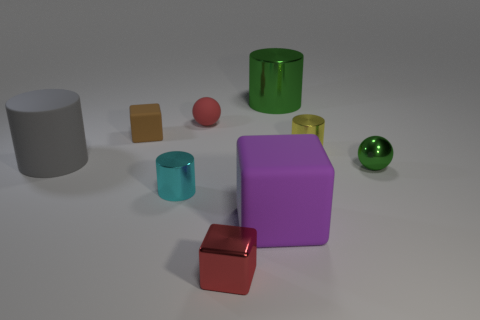Subtract all cylinders. How many objects are left? 5 Add 1 large things. How many large things are left? 4 Add 2 tiny green rubber cubes. How many tiny green rubber cubes exist? 2 Subtract 1 green cylinders. How many objects are left? 8 Subtract all big red matte cylinders. Subtract all large purple objects. How many objects are left? 8 